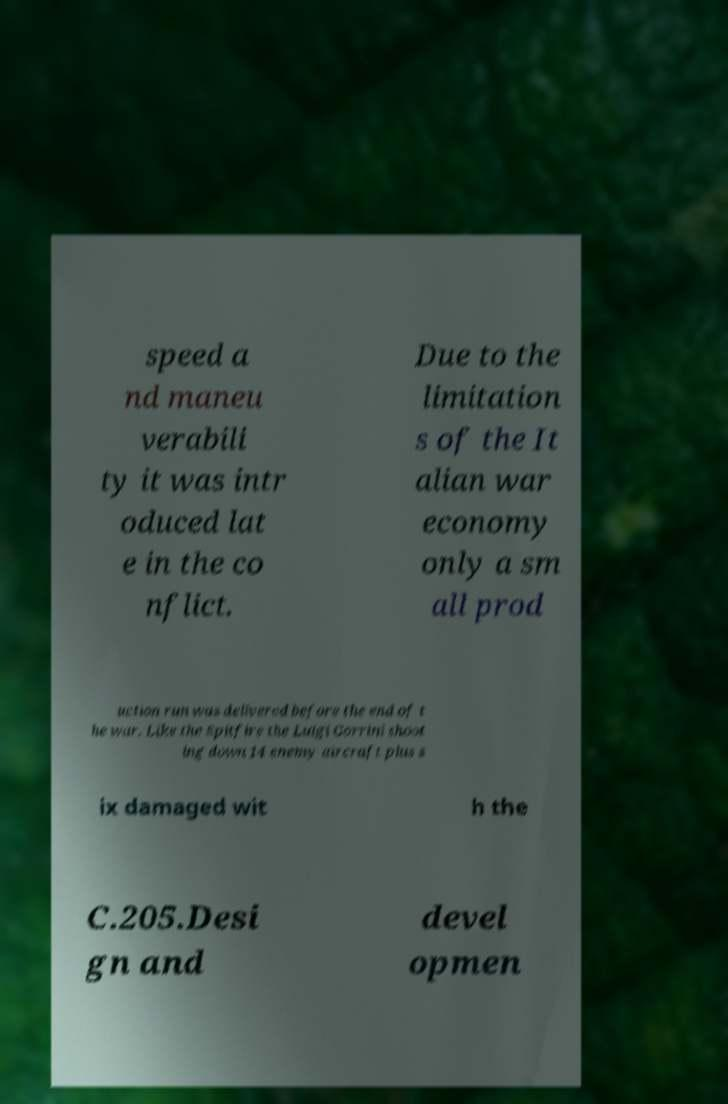There's text embedded in this image that I need extracted. Can you transcribe it verbatim? speed a nd maneu verabili ty it was intr oduced lat e in the co nflict. Due to the limitation s of the It alian war economy only a sm all prod uction run was delivered before the end of t he war. Like the Spitfire the Luigi Gorrini shoot ing down 14 enemy aircraft plus s ix damaged wit h the C.205.Desi gn and devel opmen 